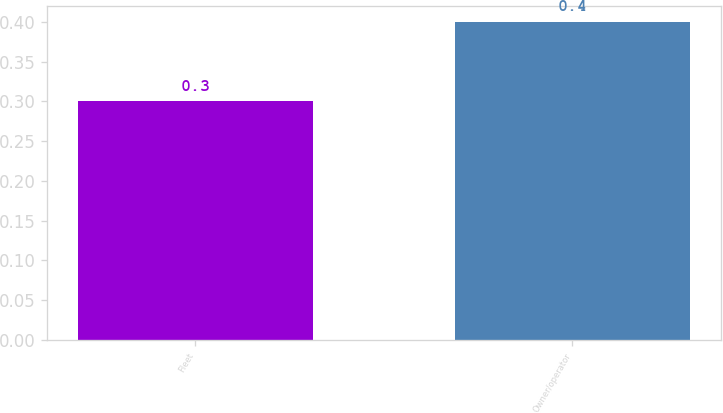Convert chart to OTSL. <chart><loc_0><loc_0><loc_500><loc_500><bar_chart><fcel>Fleet<fcel>Owner/operator<nl><fcel>0.3<fcel>0.4<nl></chart> 